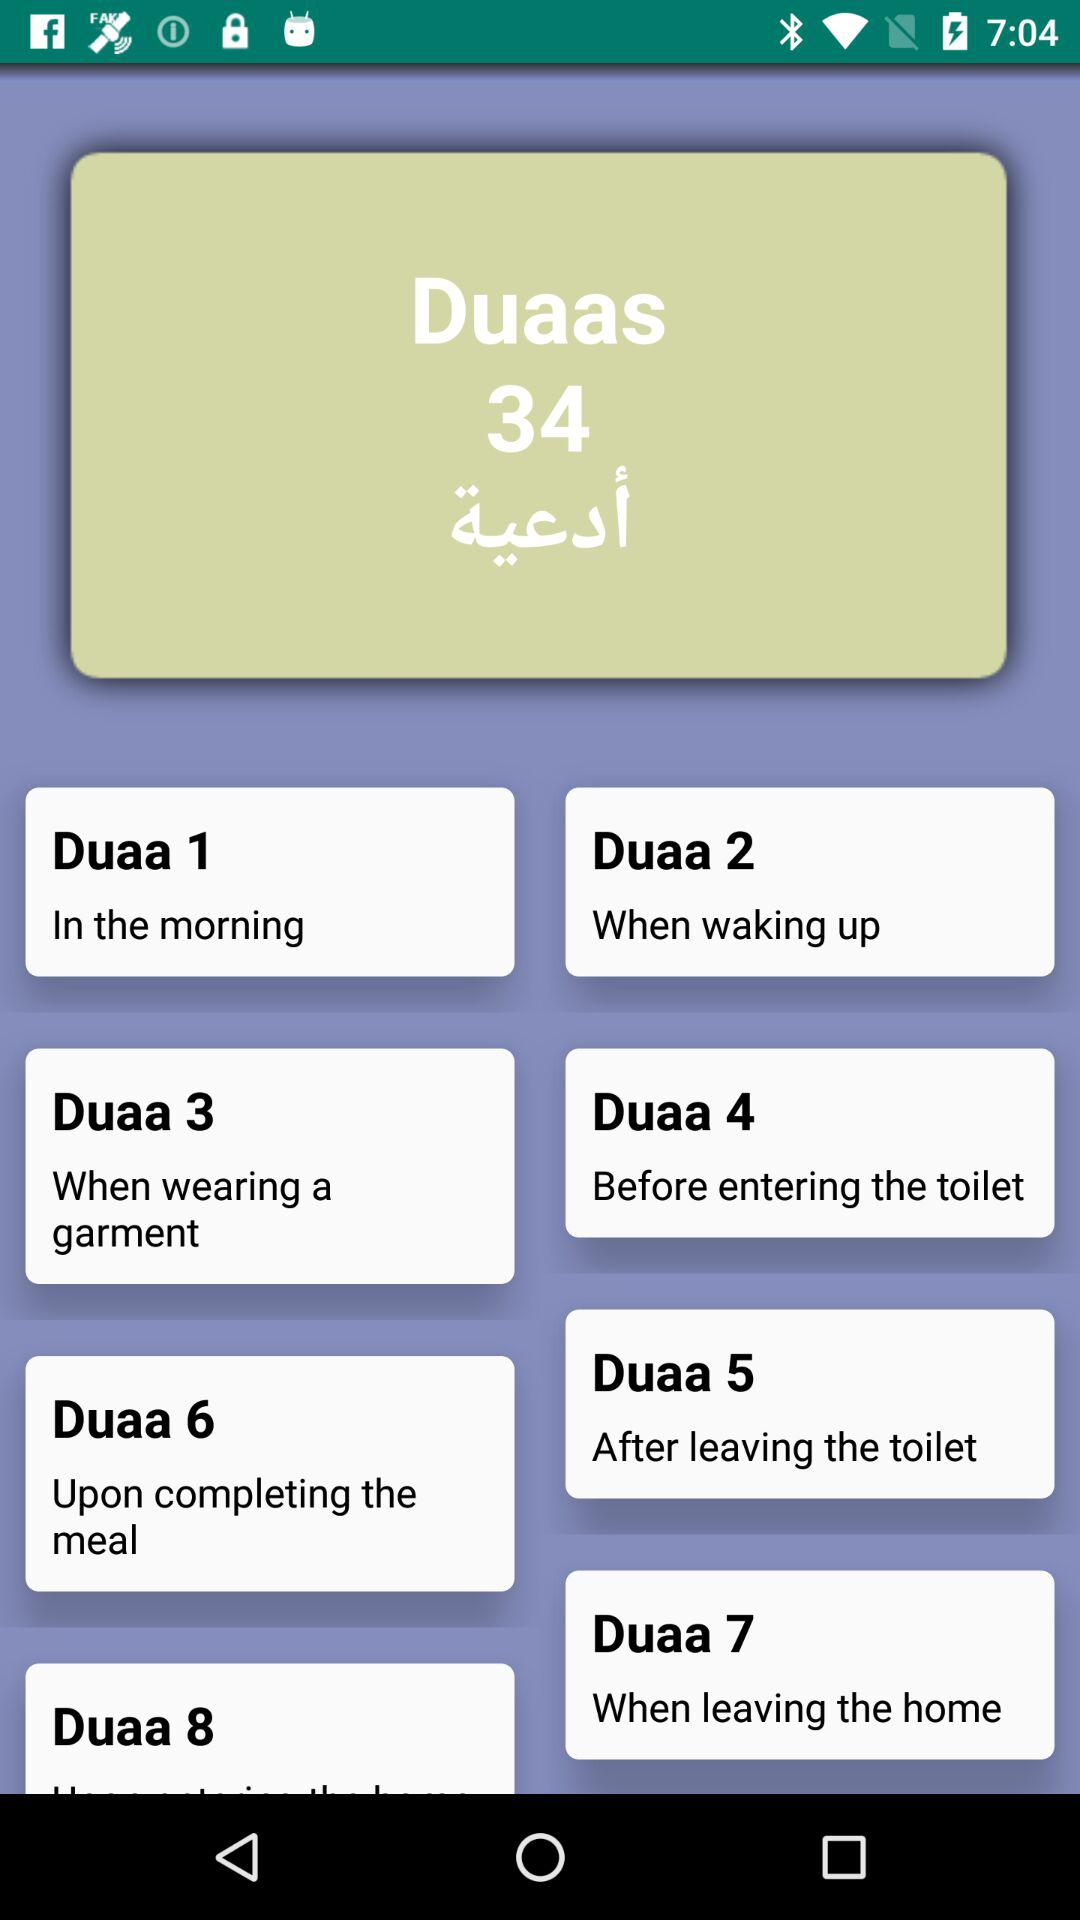How many duaas in total are there? There are 34 duaas in total. 